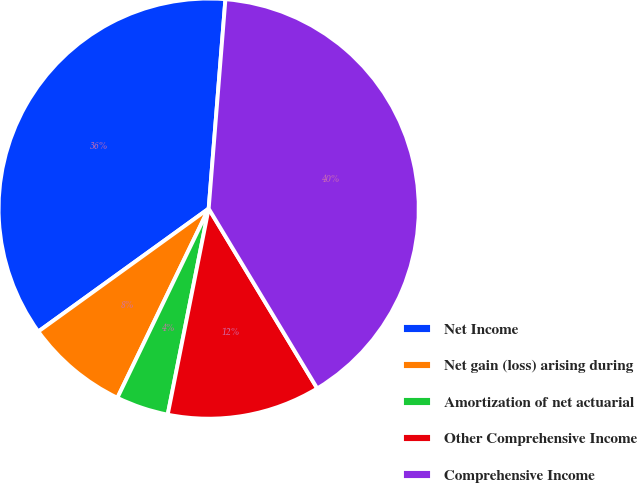Convert chart. <chart><loc_0><loc_0><loc_500><loc_500><pie_chart><fcel>Net Income<fcel>Net gain (loss) arising during<fcel>Amortization of net actuarial<fcel>Other Comprehensive Income<fcel>Comprehensive Income<nl><fcel>36.22%<fcel>7.9%<fcel>4.03%<fcel>11.77%<fcel>40.09%<nl></chart> 